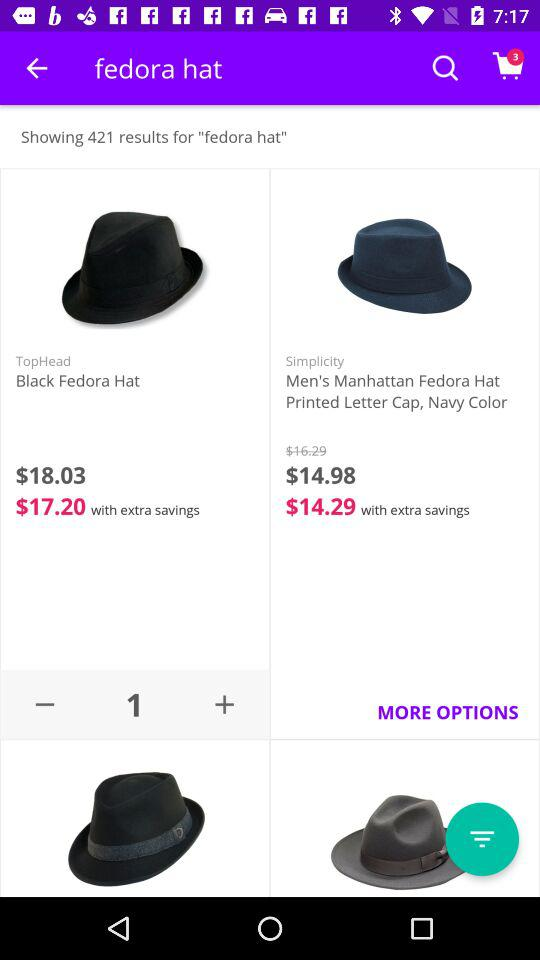What is the price of the "Black Fedora Hat"? The price of the "Black Fedora Hat" is $18.03. 